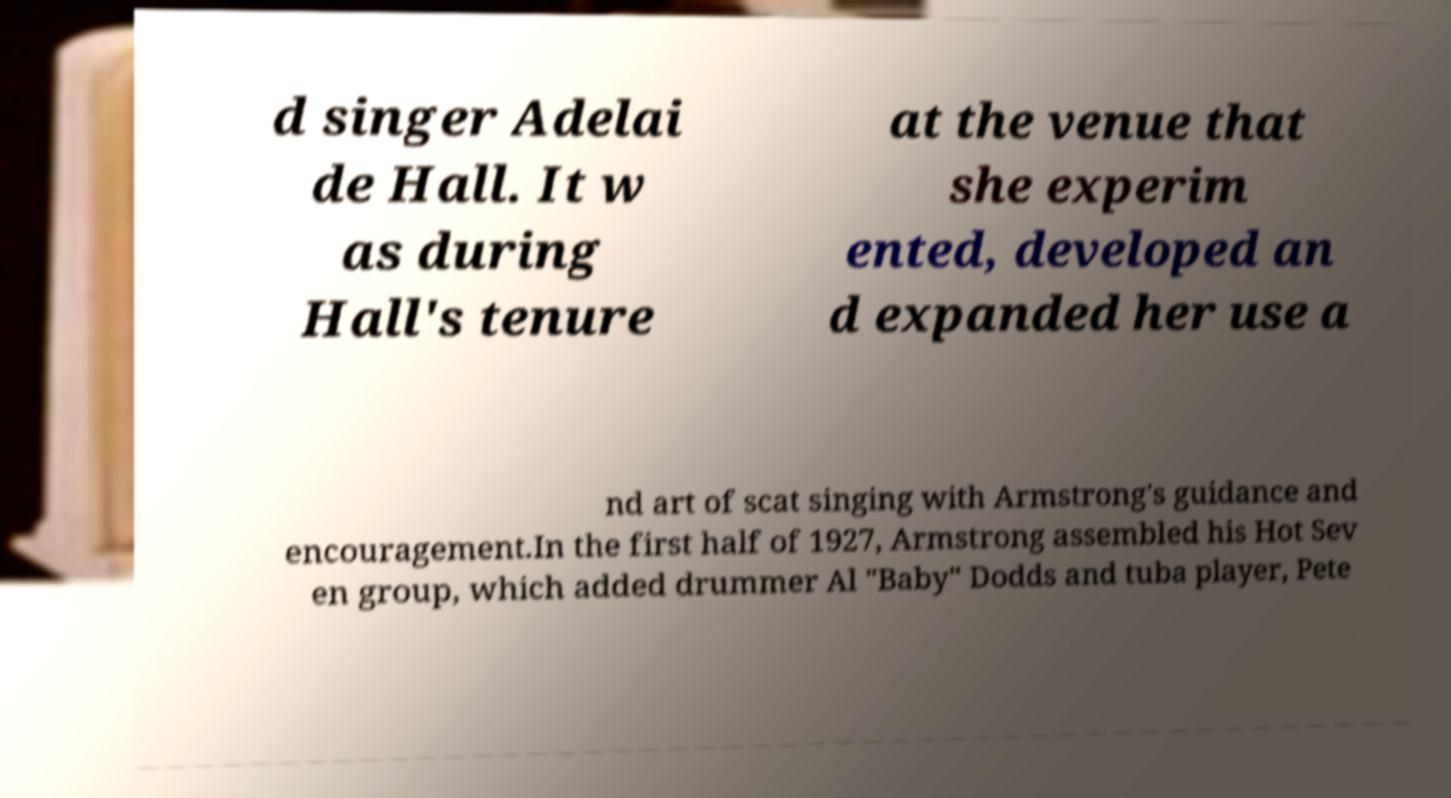Can you read and provide the text displayed in the image?This photo seems to have some interesting text. Can you extract and type it out for me? d singer Adelai de Hall. It w as during Hall's tenure at the venue that she experim ented, developed an d expanded her use a nd art of scat singing with Armstrong's guidance and encouragement.In the first half of 1927, Armstrong assembled his Hot Sev en group, which added drummer Al "Baby" Dodds and tuba player, Pete 